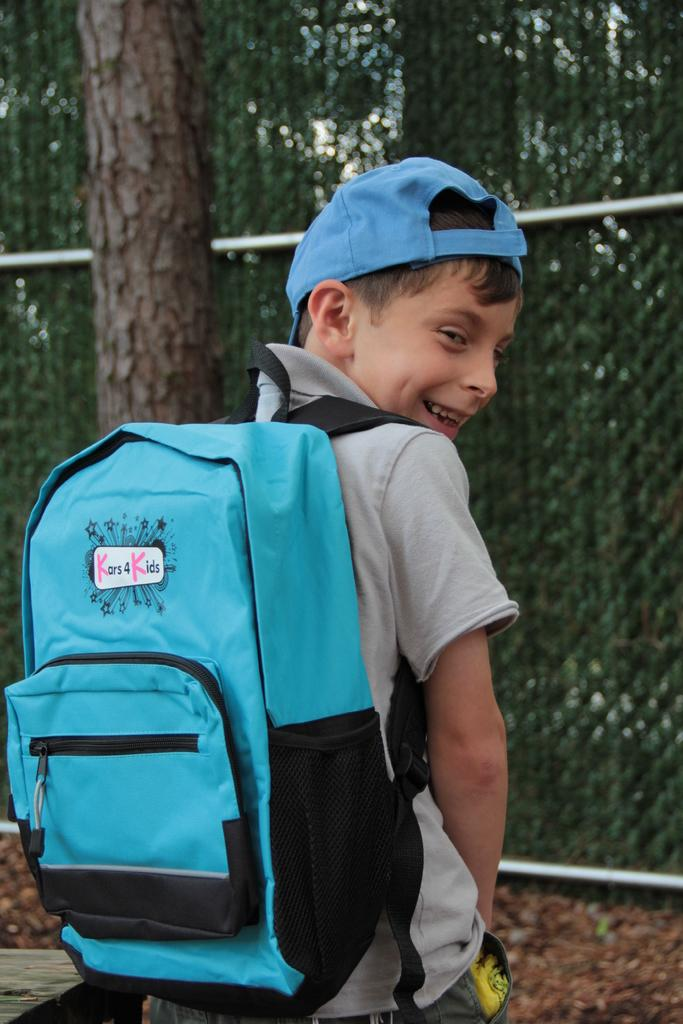<image>
Describe the image concisely. A boy walking near a fence looks back over his shoulder on which he carries a blue backpack advertising Kars 4 Kids. 